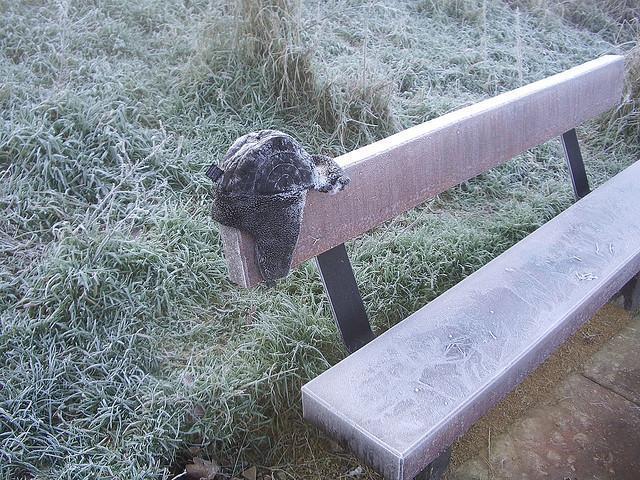How many people in the image have on backpacks?
Give a very brief answer. 0. 